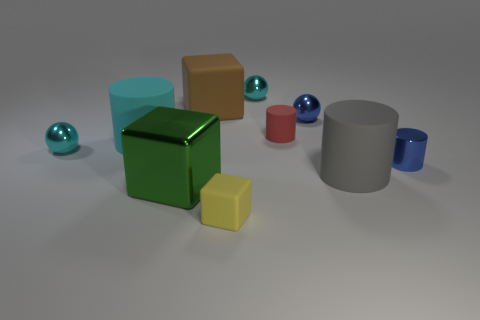Are there an equal number of small red matte cylinders that are behind the metallic cylinder and large gray metal spheres?
Offer a very short reply. No. The gray thing that is the same size as the green object is what shape?
Give a very brief answer. Cylinder. What number of other things are the same shape as the large green object?
Your answer should be very brief. 2. Is the size of the blue cylinder the same as the matte thing that is behind the tiny red object?
Offer a very short reply. No. How many things are either tiny objects in front of the tiny red thing or tiny yellow things?
Ensure brevity in your answer.  3. The small rubber object that is to the left of the tiny red matte object has what shape?
Your answer should be compact. Cube. Are there an equal number of large gray rubber objects behind the small blue cylinder and small yellow matte cubes behind the cyan matte cylinder?
Provide a short and direct response. Yes. What color is the cylinder that is both right of the small matte cylinder and behind the big gray matte cylinder?
Offer a terse response. Blue. What material is the big gray cylinder that is in front of the cyan metallic ball that is behind the tiny red cylinder?
Provide a succinct answer. Rubber. Does the green thing have the same size as the gray rubber object?
Make the answer very short. Yes. 